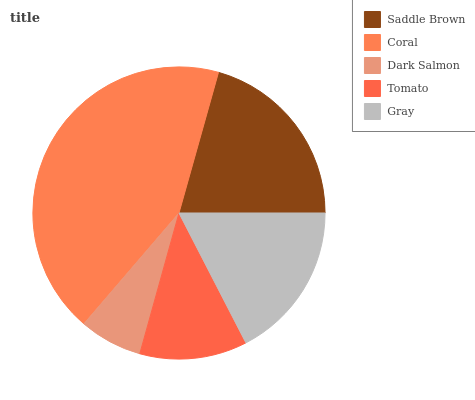Is Dark Salmon the minimum?
Answer yes or no. Yes. Is Coral the maximum?
Answer yes or no. Yes. Is Coral the minimum?
Answer yes or no. No. Is Dark Salmon the maximum?
Answer yes or no. No. Is Coral greater than Dark Salmon?
Answer yes or no. Yes. Is Dark Salmon less than Coral?
Answer yes or no. Yes. Is Dark Salmon greater than Coral?
Answer yes or no. No. Is Coral less than Dark Salmon?
Answer yes or no. No. Is Gray the high median?
Answer yes or no. Yes. Is Gray the low median?
Answer yes or no. Yes. Is Coral the high median?
Answer yes or no. No. Is Dark Salmon the low median?
Answer yes or no. No. 